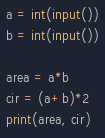<code> <loc_0><loc_0><loc_500><loc_500><_Python_>a = int(input())
b = int(input())

area = a*b
cir = (a+b)*2
print(area, cir)</code> 